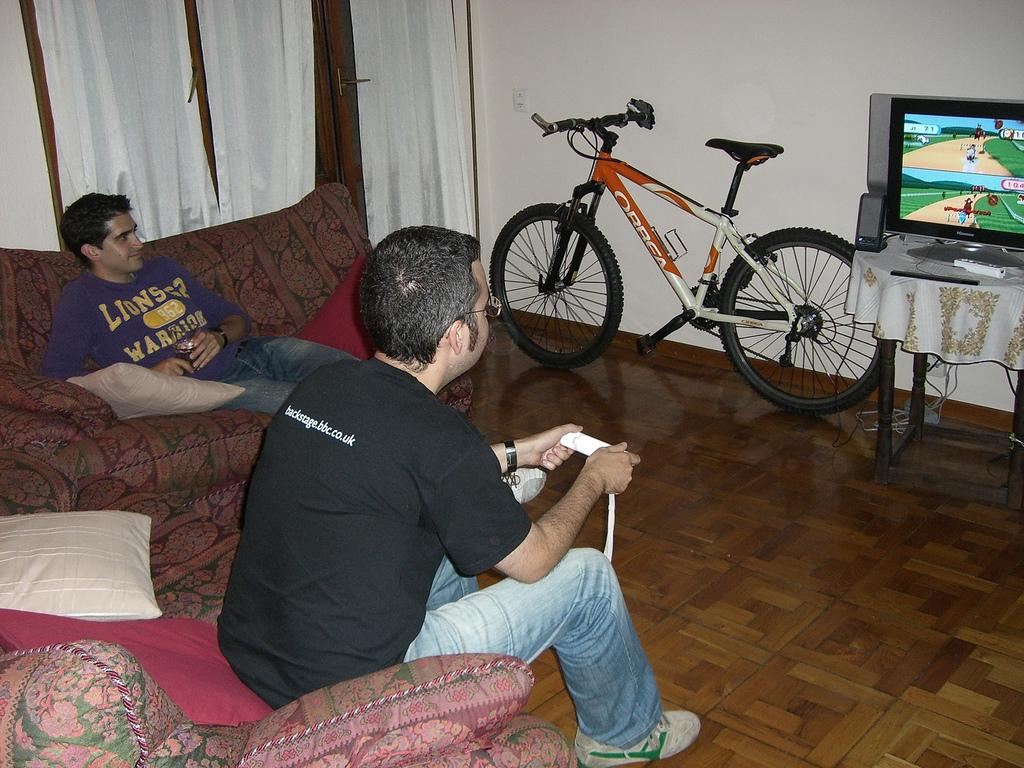Enumerate three furniture items or appliances found in the image. A TV on a table, a speaker beside the TV, and a table with a white and gold tablecloth can be seen. Mention an activity happening in the image and the person performing it. A man wearing a black shirt and glasses is holding a controller, presumably playing a video game. Describe a fashion accessory worn by the man in the image. The man is wearing a watch on his wrist. Describe the scene in the image including the person, their attire, and their surroundings. In the image, a man wearing a black shirt, blue jeans, glasses, and a watch is holding a controller, with a bike and a TV in the background. List three prominent objects in the image and their respective colors. A dark pink pillow, a light pink pillow, and a beige pillow are all visible in the image. Mention two distinct characteristics about the floor in the image. The floor in the image is brown and shiny. Briefly describe the person and their physical appearance in the image. The man in the image has short black hair, wears glasses, a black shirt, blue jeans, and a watch. Identify the location of the bike in the image and its associated features. The bike is positioned against the wall and has an orange and white object nearby, with its front tire visible. 